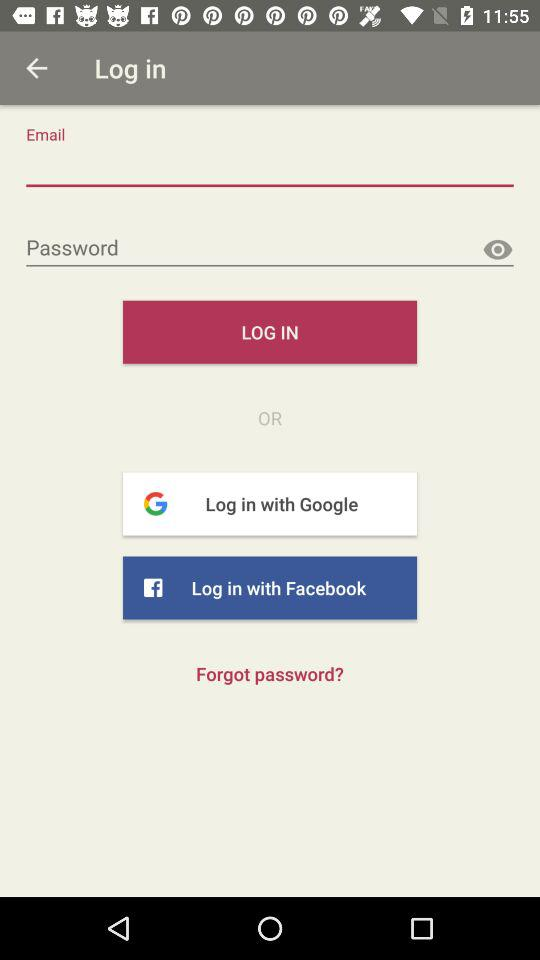Which application can we log in with? You can log in with "Google" and "Facebook". 